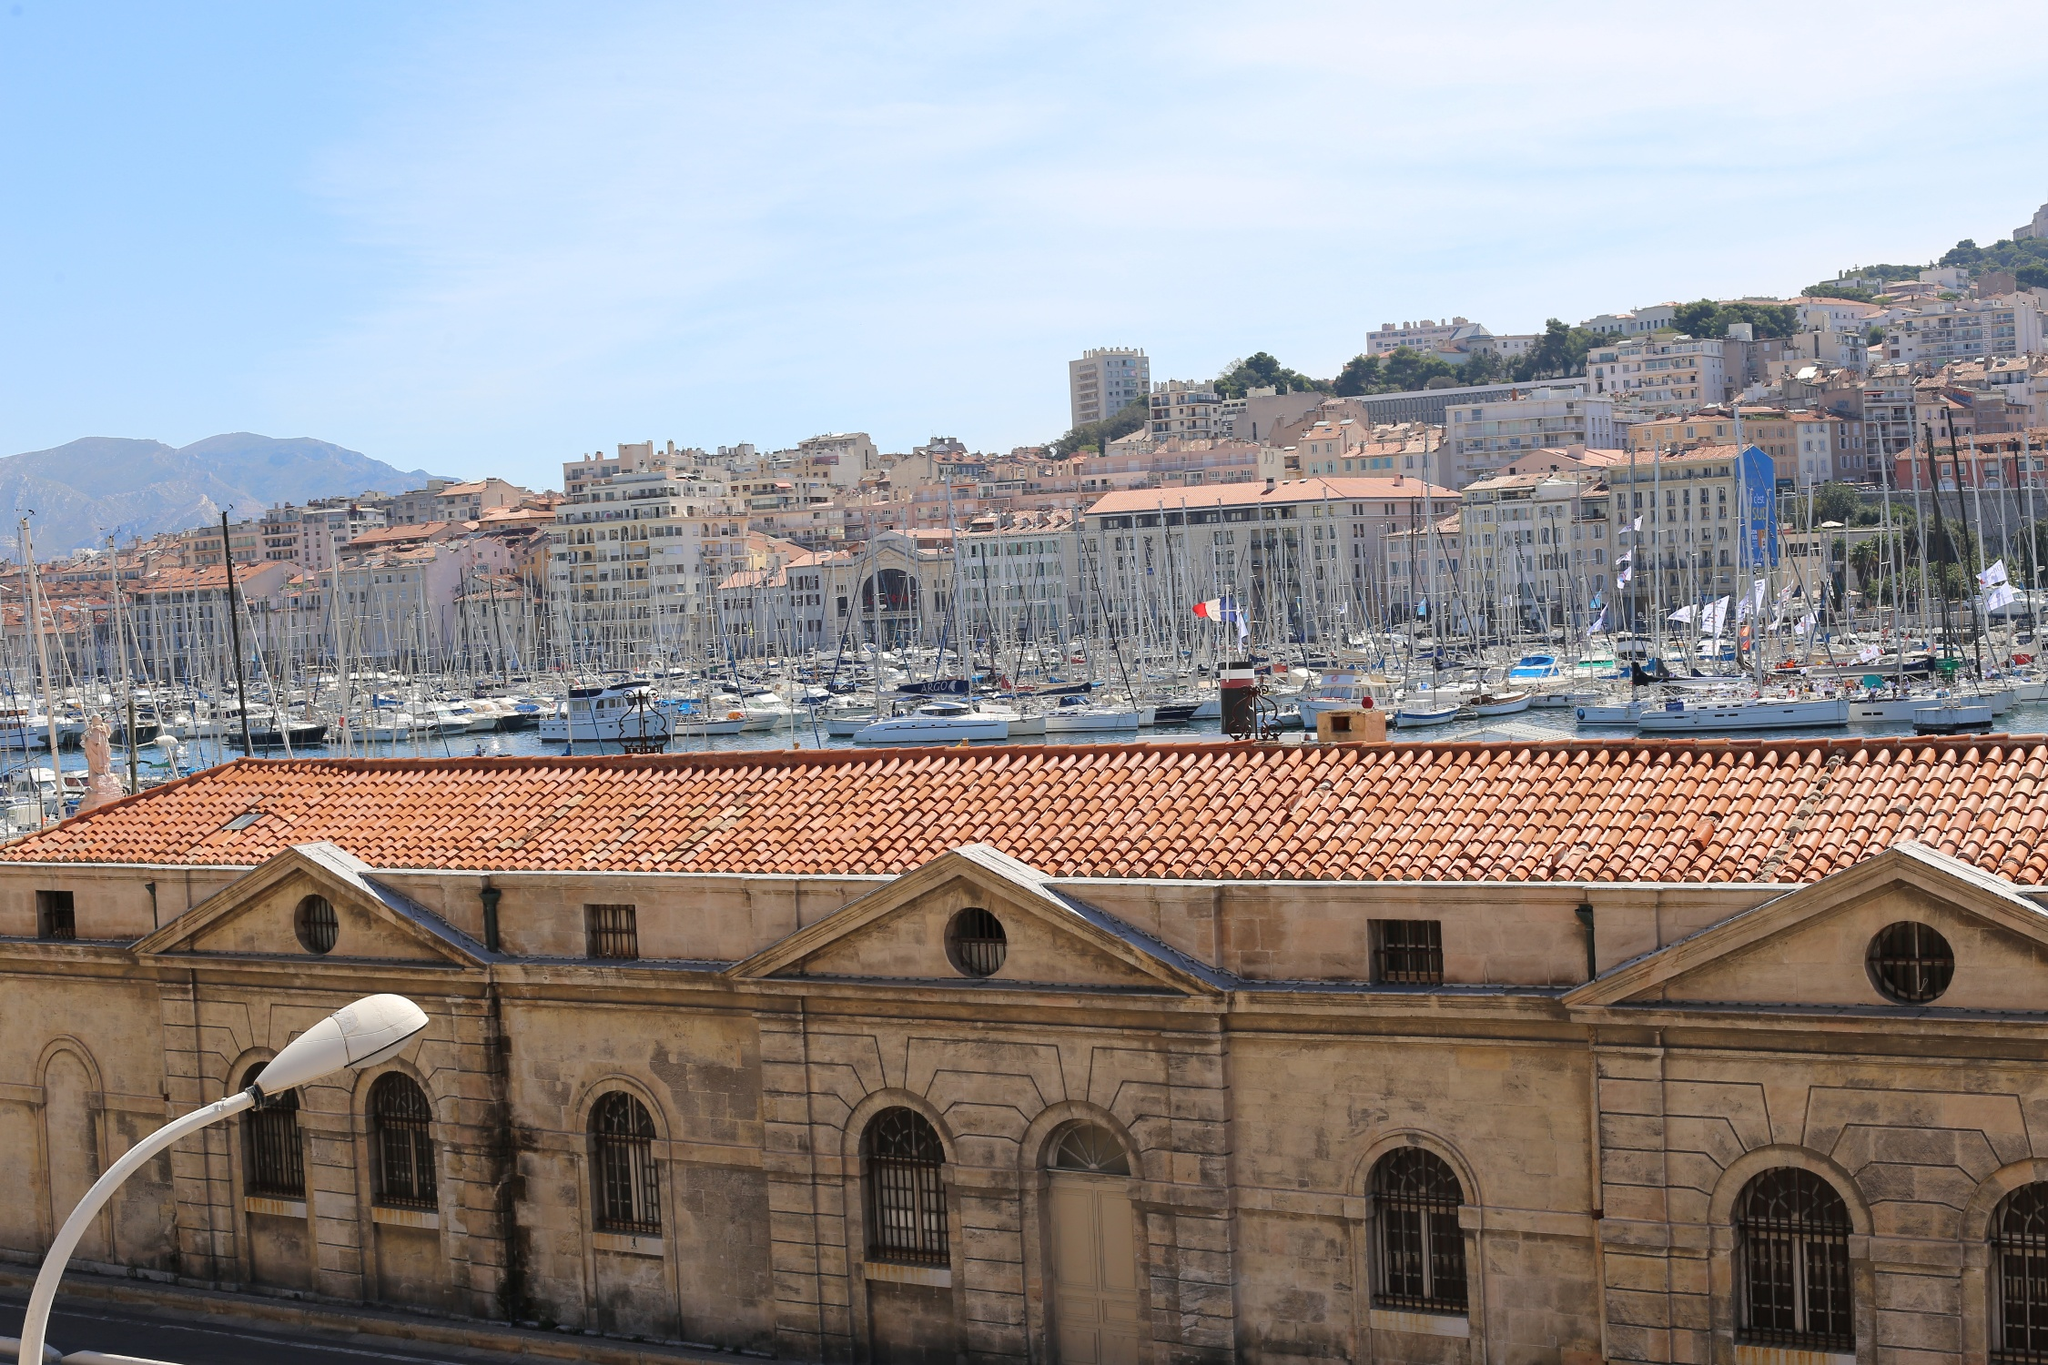Imagine a futuristic version of the Old Port of Marseille. What advancements and changes could we expect to see? In a futuristic version of the Old Port of Marseille, the port would boast remarkable technological advancements while preserving its historic charm. The marina might be home to sleek, eco-friendly yachts powered by renewable energy. The waters could be inhabited by automated, self-cleaning boats that maintain the port's cleanliness. Advanced digital displays provide real-time information about the history and significance of different landmarks, blending augmented reality with the rich cultural landscape. Smart streetlights powered by solar energy ensure eco-friendly illumination, while drone taxis zip through the air providing quick and efficient transportation around the city. The historic buildings could be equipped with both modern amenities and holographic displays, telling stories of the past in an interactive manner. Even markets and shops may feature smart vending systems, offering local delicacies with the convenience of cashless, automated transactions. As night falls, the entire port illuminates with colorful light shows projected onto the water, creating a stunning blend of technology and tradition. 